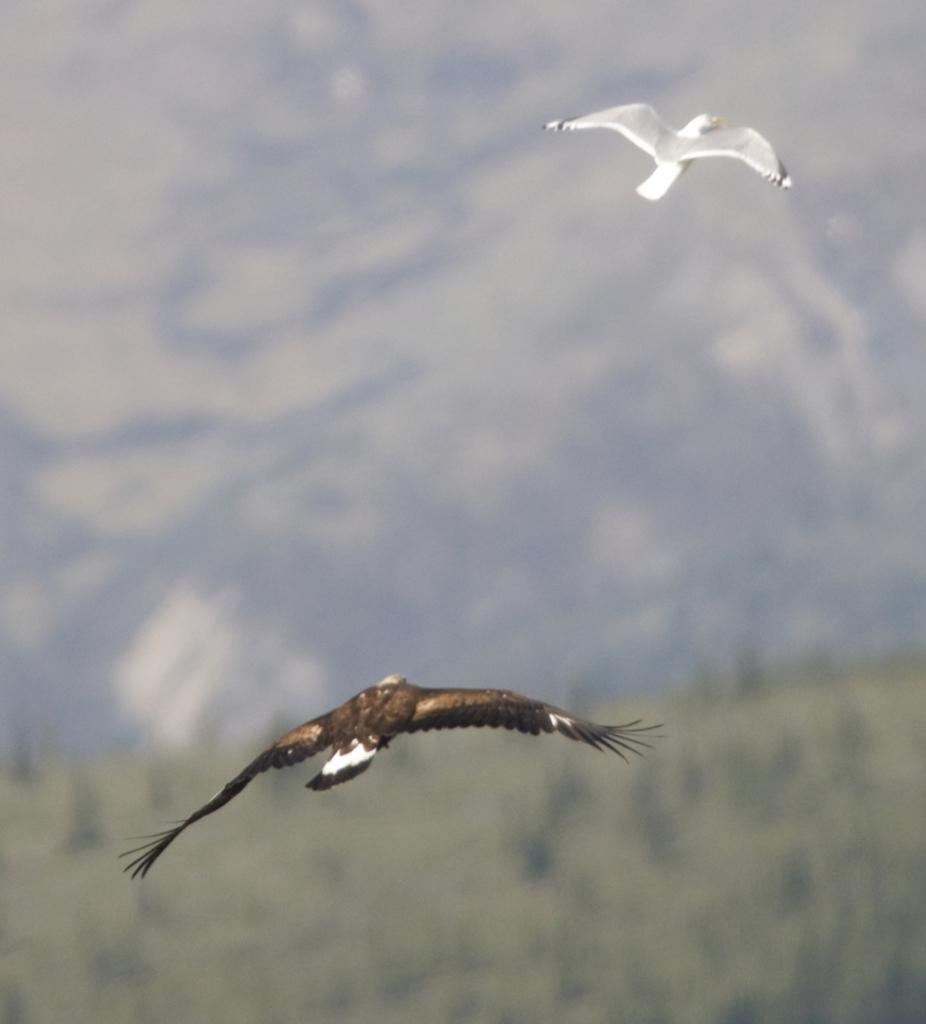How many birds are present in the image? There are two birds in the image. What are the birds doing in the image? The birds are flying in the air. What type of ray can be seen swimming in the water near the birds? There is no ray or water present in the image; it features two birds flying in the air. What type of doll is sitting on the branch with the birds? There is no doll present in the image; it features two birds flying in the air. 